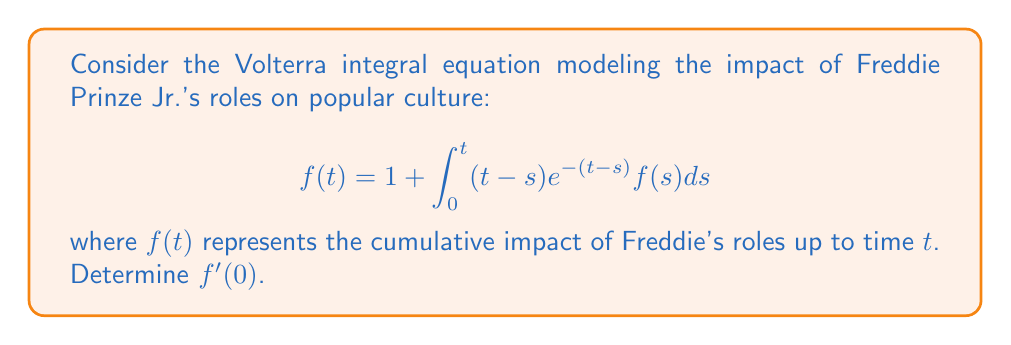Teach me how to tackle this problem. To find $f'(0)$, we need to differentiate both sides of the equation with respect to $t$ and then evaluate at $t=0$:

1) Differentiate the left-hand side:
   $$\frac{d}{dt}f(t) = f'(t)$$

2) Differentiate the right-hand side using the Leibniz integral rule:
   $$\frac{d}{dt}\left[1 + \int_0^t (t-s)e^{-(t-s)}f(s)ds\right] = 0 + \int_0^t \frac{\partial}{\partial t}[(t-s)e^{-(t-s)}]f(s)ds + (t-t)e^{-(t-t)}f(t)$$

3) Simplify:
   $$f'(t) = \int_0^t [e^{-(t-s)} - (t-s)e^{-(t-s)}]f(s)ds + 0$$

4) Evaluate at $t=0$:
   $$f'(0) = \int_0^0 [e^{-(0-s)} - (0-s)e^{-(0-s)}]f(s)ds = 0$$

Therefore, $f'(0) = 0$.
Answer: $f'(0) = 0$ 